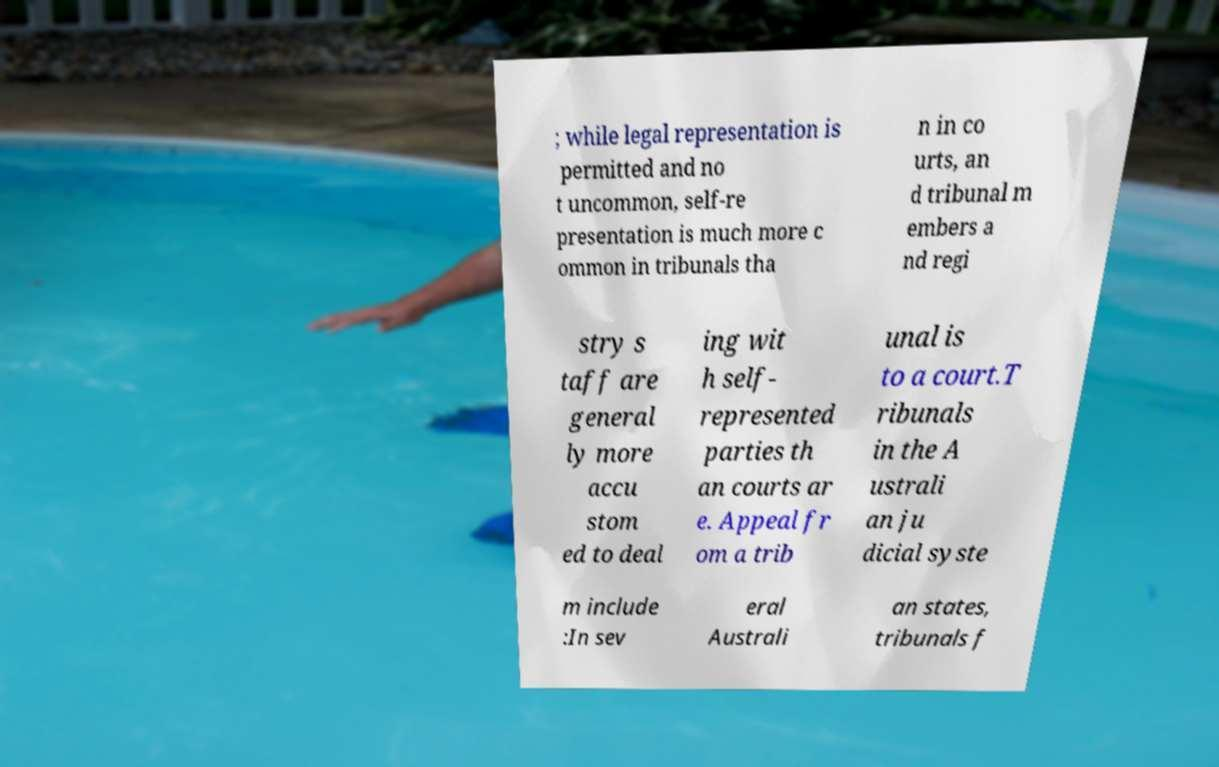Can you read and provide the text displayed in the image?This photo seems to have some interesting text. Can you extract and type it out for me? ; while legal representation is permitted and no t uncommon, self-re presentation is much more c ommon in tribunals tha n in co urts, an d tribunal m embers a nd regi stry s taff are general ly more accu stom ed to deal ing wit h self- represented parties th an courts ar e. Appeal fr om a trib unal is to a court.T ribunals in the A ustrali an ju dicial syste m include :In sev eral Australi an states, tribunals f 